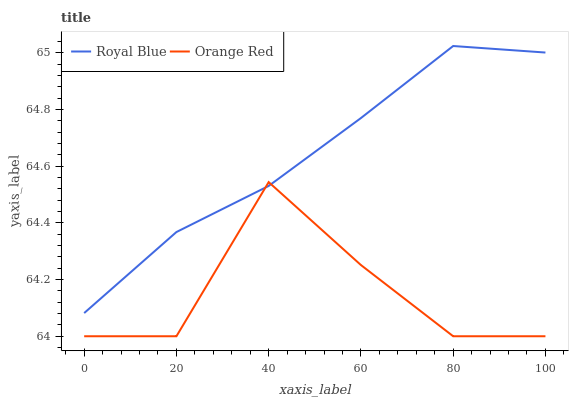Does Orange Red have the minimum area under the curve?
Answer yes or no. Yes. Does Royal Blue have the maximum area under the curve?
Answer yes or no. Yes. Does Orange Red have the maximum area under the curve?
Answer yes or no. No. Is Royal Blue the smoothest?
Answer yes or no. Yes. Is Orange Red the roughest?
Answer yes or no. Yes. Is Orange Red the smoothest?
Answer yes or no. No. Does Orange Red have the lowest value?
Answer yes or no. Yes. Does Royal Blue have the highest value?
Answer yes or no. Yes. Does Orange Red have the highest value?
Answer yes or no. No. Does Orange Red intersect Royal Blue?
Answer yes or no. Yes. Is Orange Red less than Royal Blue?
Answer yes or no. No. Is Orange Red greater than Royal Blue?
Answer yes or no. No. 